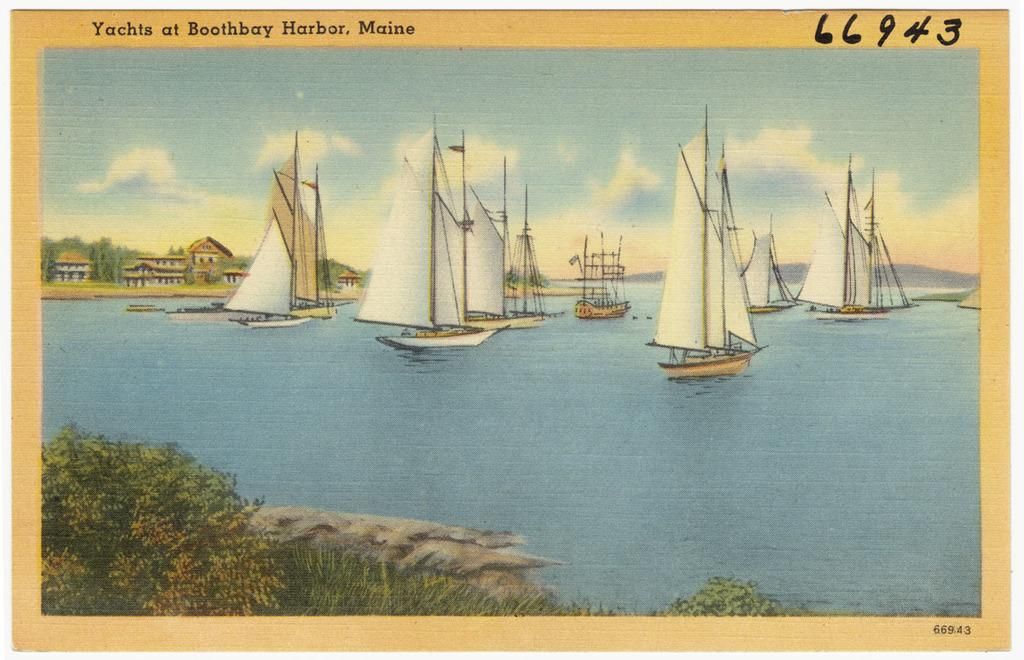<image>
Offer a succinct explanation of the picture presented. postcard 66943 of yachts at boothbay harbor maine 